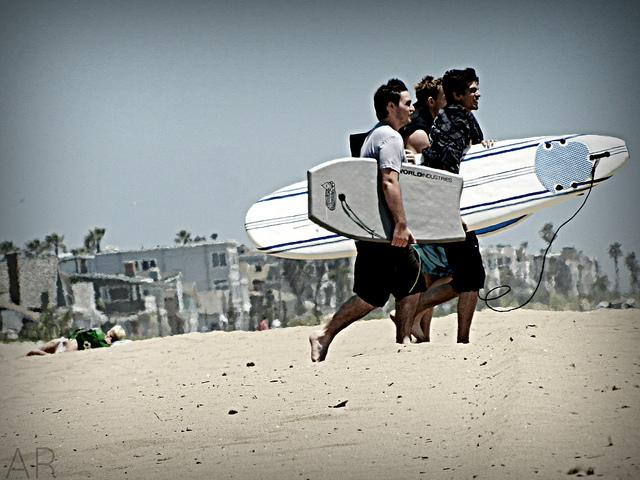Are these boards tied to the people?
Write a very short answer. Yes. What is he carrying on his hand?
Answer briefly. Surfboard. Do these boards have different uses?
Give a very brief answer. Yes. 